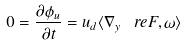<formula> <loc_0><loc_0><loc_500><loc_500>0 = \frac { \partial \phi _ { u } } { \partial t } = u _ { d } \langle \nabla _ { y } \ r e F , \omega \rangle</formula> 